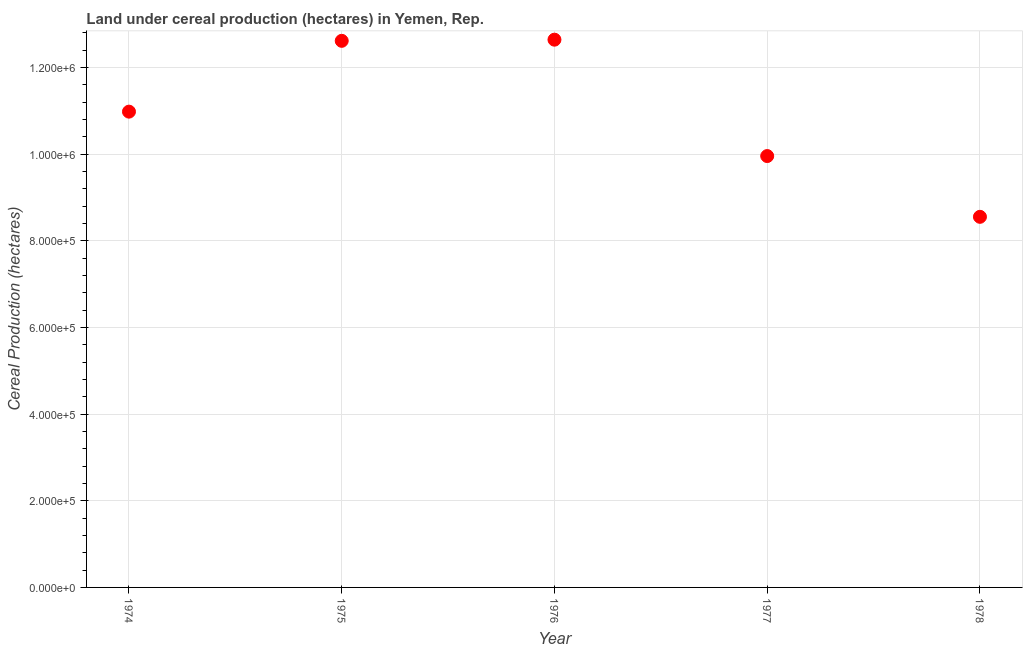What is the land under cereal production in 1978?
Keep it short and to the point. 8.56e+05. Across all years, what is the maximum land under cereal production?
Your answer should be very brief. 1.26e+06. Across all years, what is the minimum land under cereal production?
Offer a very short reply. 8.56e+05. In which year was the land under cereal production maximum?
Ensure brevity in your answer.  1976. In which year was the land under cereal production minimum?
Keep it short and to the point. 1978. What is the sum of the land under cereal production?
Your response must be concise. 5.48e+06. What is the difference between the land under cereal production in 1977 and 1978?
Provide a succinct answer. 1.40e+05. What is the average land under cereal production per year?
Provide a short and direct response. 1.10e+06. What is the median land under cereal production?
Your response must be concise. 1.10e+06. Do a majority of the years between 1978 and 1976 (inclusive) have land under cereal production greater than 320000 hectares?
Offer a terse response. No. What is the ratio of the land under cereal production in 1975 to that in 1977?
Ensure brevity in your answer.  1.27. Is the land under cereal production in 1975 less than that in 1977?
Keep it short and to the point. No. Is the difference between the land under cereal production in 1977 and 1978 greater than the difference between any two years?
Give a very brief answer. No. What is the difference between the highest and the second highest land under cereal production?
Your answer should be very brief. 2667. What is the difference between the highest and the lowest land under cereal production?
Ensure brevity in your answer.  4.09e+05. In how many years, is the land under cereal production greater than the average land under cereal production taken over all years?
Offer a terse response. 3. How many years are there in the graph?
Ensure brevity in your answer.  5. What is the difference between two consecutive major ticks on the Y-axis?
Offer a very short reply. 2.00e+05. Does the graph contain any zero values?
Give a very brief answer. No. What is the title of the graph?
Your answer should be compact. Land under cereal production (hectares) in Yemen, Rep. What is the label or title of the Y-axis?
Offer a very short reply. Cereal Production (hectares). What is the Cereal Production (hectares) in 1974?
Your response must be concise. 1.10e+06. What is the Cereal Production (hectares) in 1975?
Give a very brief answer. 1.26e+06. What is the Cereal Production (hectares) in 1976?
Offer a terse response. 1.26e+06. What is the Cereal Production (hectares) in 1977?
Keep it short and to the point. 9.96e+05. What is the Cereal Production (hectares) in 1978?
Your answer should be compact. 8.56e+05. What is the difference between the Cereal Production (hectares) in 1974 and 1975?
Make the answer very short. -1.63e+05. What is the difference between the Cereal Production (hectares) in 1974 and 1976?
Give a very brief answer. -1.66e+05. What is the difference between the Cereal Production (hectares) in 1974 and 1977?
Make the answer very short. 1.03e+05. What is the difference between the Cereal Production (hectares) in 1974 and 1978?
Provide a short and direct response. 2.43e+05. What is the difference between the Cereal Production (hectares) in 1975 and 1976?
Provide a short and direct response. -2667. What is the difference between the Cereal Production (hectares) in 1975 and 1977?
Your answer should be compact. 2.66e+05. What is the difference between the Cereal Production (hectares) in 1975 and 1978?
Offer a terse response. 4.06e+05. What is the difference between the Cereal Production (hectares) in 1976 and 1977?
Give a very brief answer. 2.69e+05. What is the difference between the Cereal Production (hectares) in 1976 and 1978?
Provide a succinct answer. 4.09e+05. What is the difference between the Cereal Production (hectares) in 1977 and 1978?
Offer a very short reply. 1.40e+05. What is the ratio of the Cereal Production (hectares) in 1974 to that in 1975?
Keep it short and to the point. 0.87. What is the ratio of the Cereal Production (hectares) in 1974 to that in 1976?
Give a very brief answer. 0.87. What is the ratio of the Cereal Production (hectares) in 1974 to that in 1977?
Offer a terse response. 1.1. What is the ratio of the Cereal Production (hectares) in 1974 to that in 1978?
Offer a terse response. 1.28. What is the ratio of the Cereal Production (hectares) in 1975 to that in 1976?
Give a very brief answer. 1. What is the ratio of the Cereal Production (hectares) in 1975 to that in 1977?
Provide a succinct answer. 1.27. What is the ratio of the Cereal Production (hectares) in 1975 to that in 1978?
Your answer should be very brief. 1.48. What is the ratio of the Cereal Production (hectares) in 1976 to that in 1977?
Give a very brief answer. 1.27. What is the ratio of the Cereal Production (hectares) in 1976 to that in 1978?
Your answer should be very brief. 1.48. What is the ratio of the Cereal Production (hectares) in 1977 to that in 1978?
Make the answer very short. 1.16. 